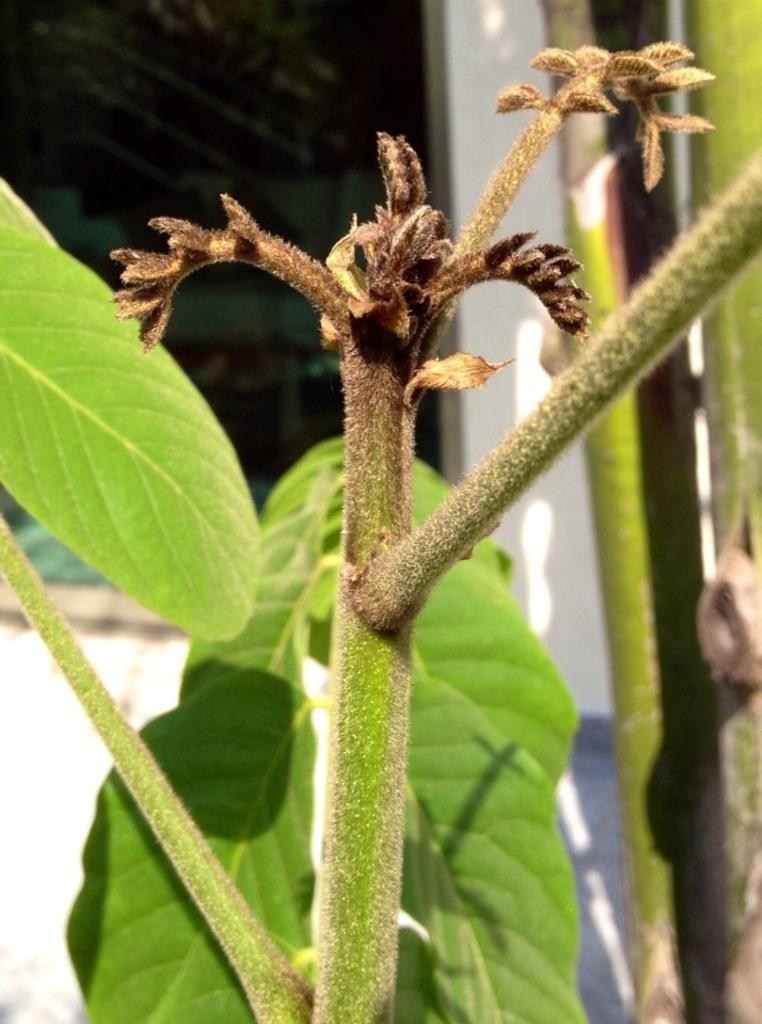Describe this image in one or two sentences. In the foreground of the picture there are leaves and stem of a plant. The background is blurred. In the background there is a window and wall painted white. 